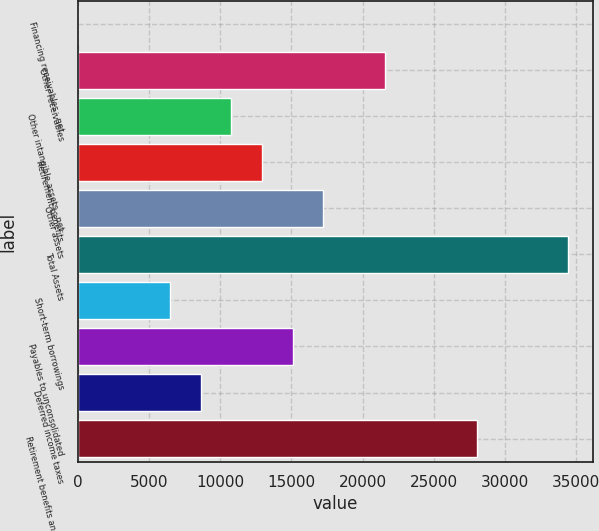<chart> <loc_0><loc_0><loc_500><loc_500><bar_chart><fcel>Financing receivables - net<fcel>Other receivables<fcel>Other intangible assets - net<fcel>Retirement benefits<fcel>Other assets<fcel>Total Assets<fcel>Short-term borrowings<fcel>Payables to unconsolidated<fcel>Deferred income taxes<fcel>Retirement benefits and other<nl><fcel>9.4<fcel>21540.9<fcel>10775.1<fcel>12928.3<fcel>17234.6<fcel>34459.8<fcel>6468.85<fcel>15081.5<fcel>8622<fcel>28000.3<nl></chart> 